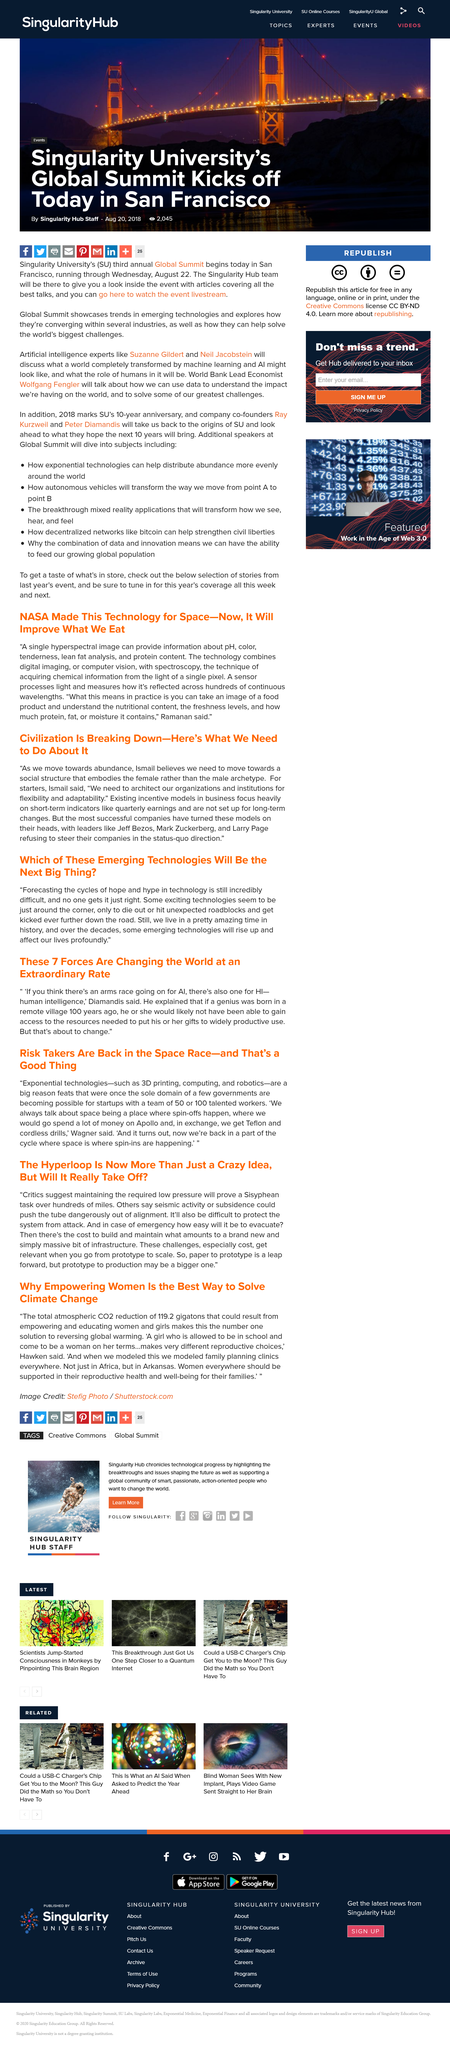Identify some key points in this picture. The construction of the hyperloop poses potential dangers such as difficulty in protecting and evacuating in the event of an emergency. On December 4th, 2019, Singularity University's third annual Global Summit took place in San Francisco, California. The start of Singularity University’s third annual Global Summit took place on August 20th, 2018. Abundance or scarcity is causing the breakdown of civilization. The hyperloop will be a extremely long distance transportation system, with a length surpassing hundreds of miles. 